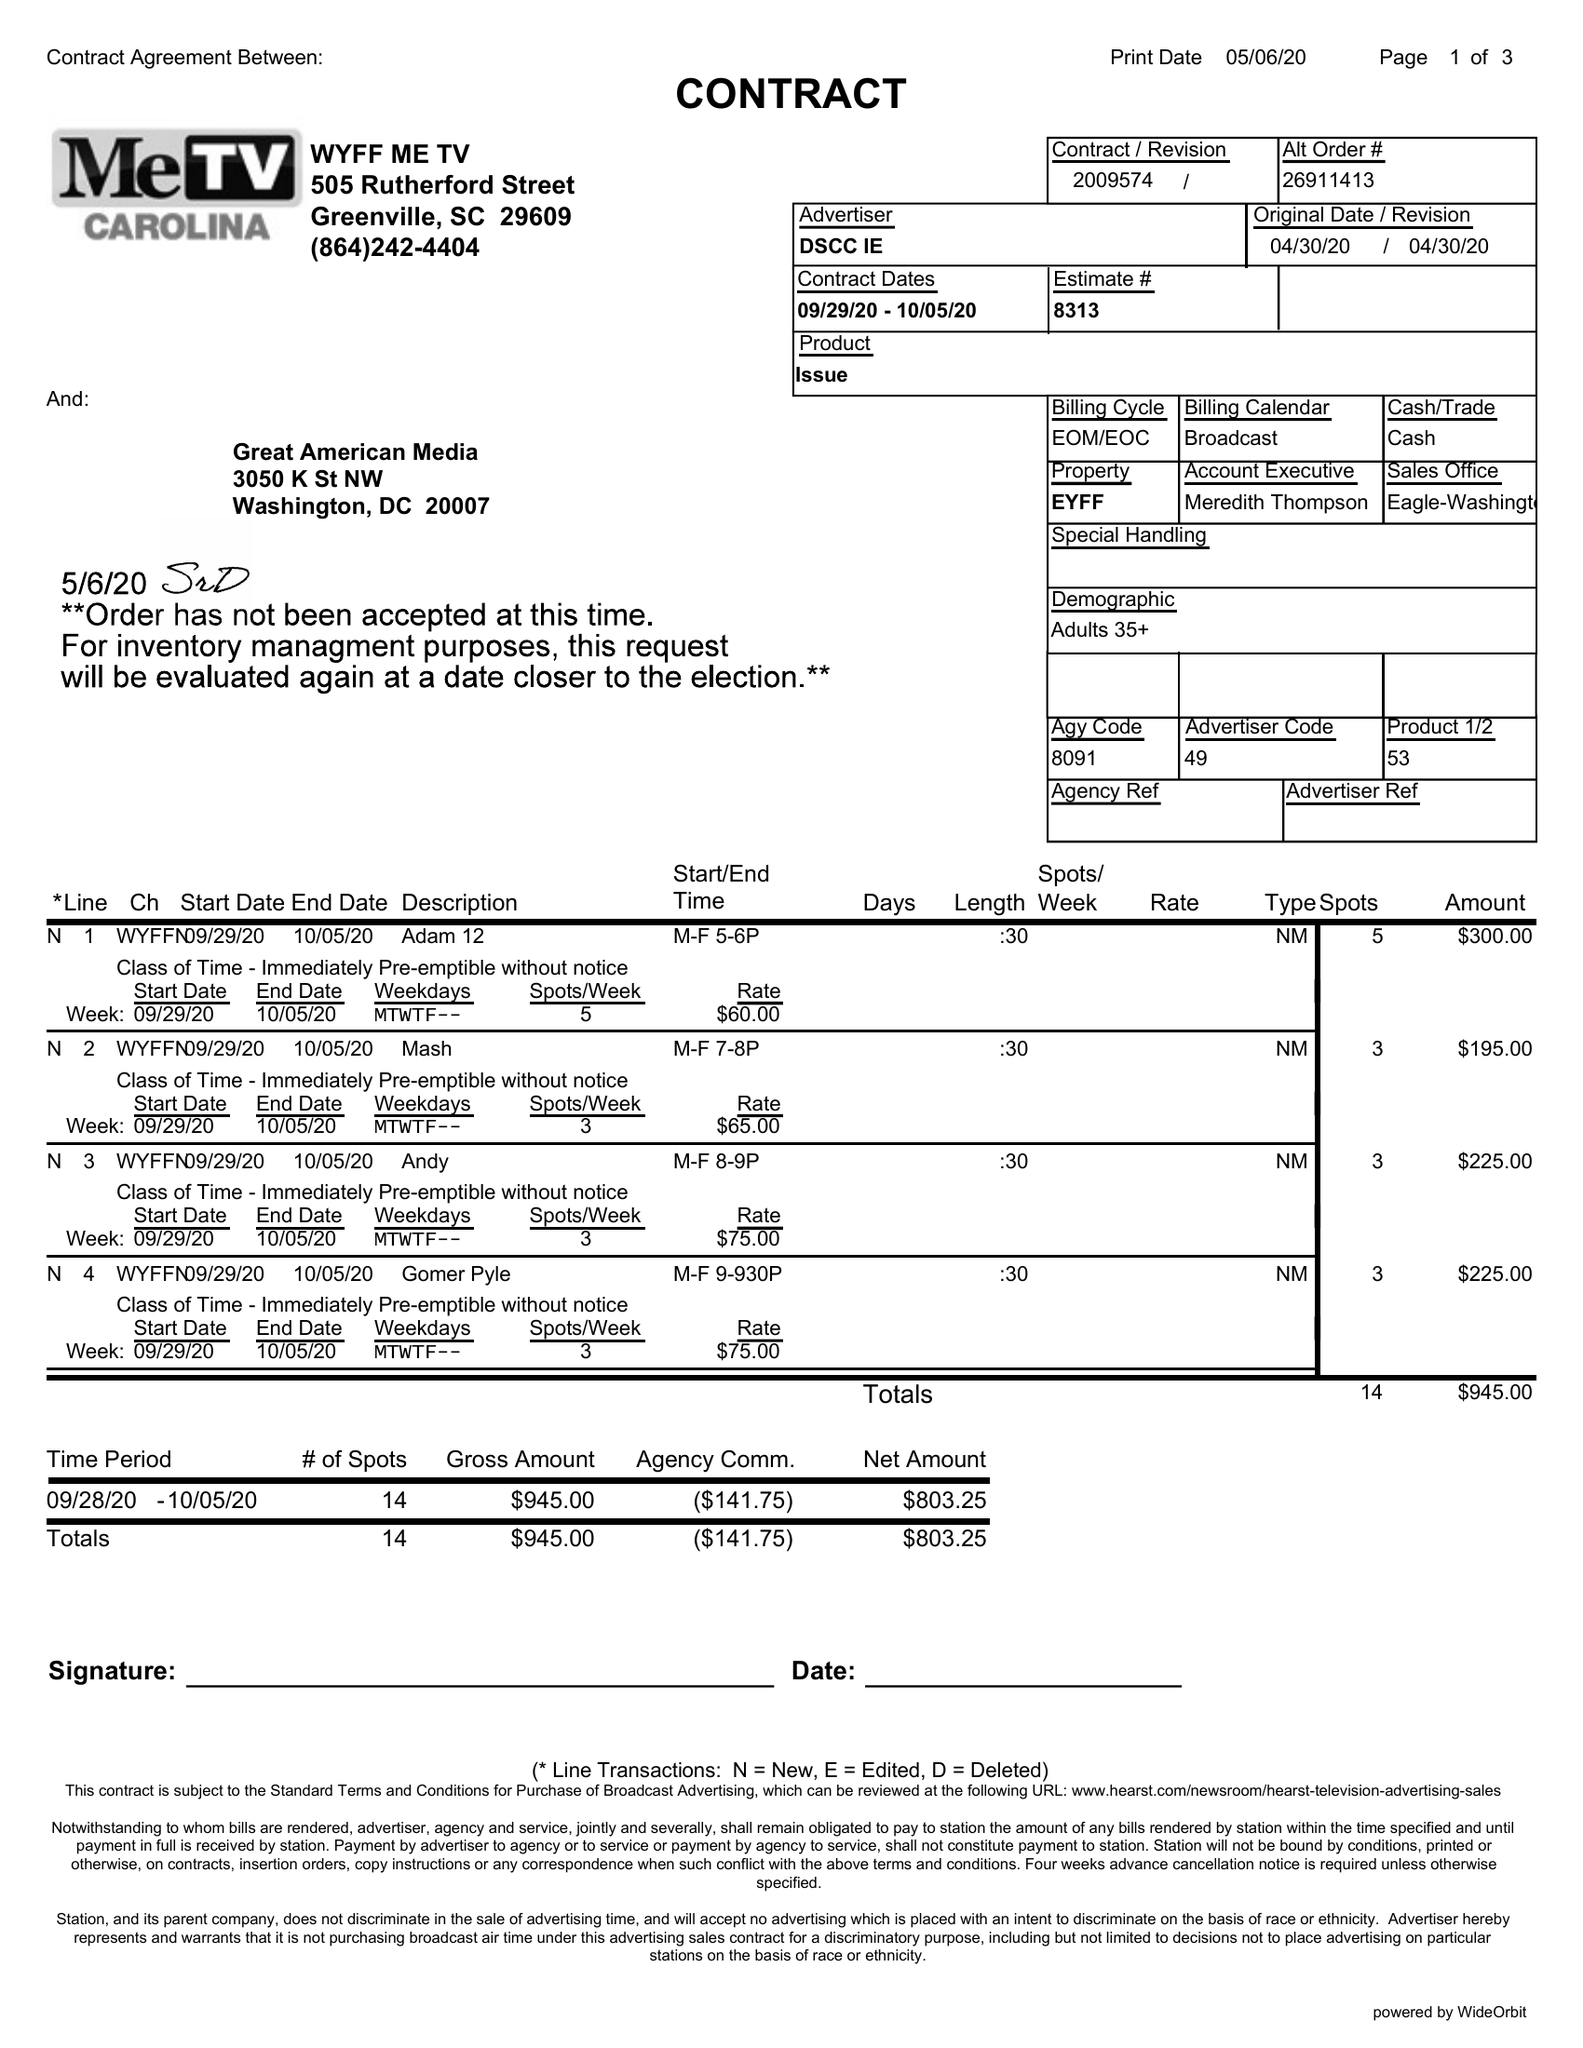What is the value for the contract_num?
Answer the question using a single word or phrase. 2009574 